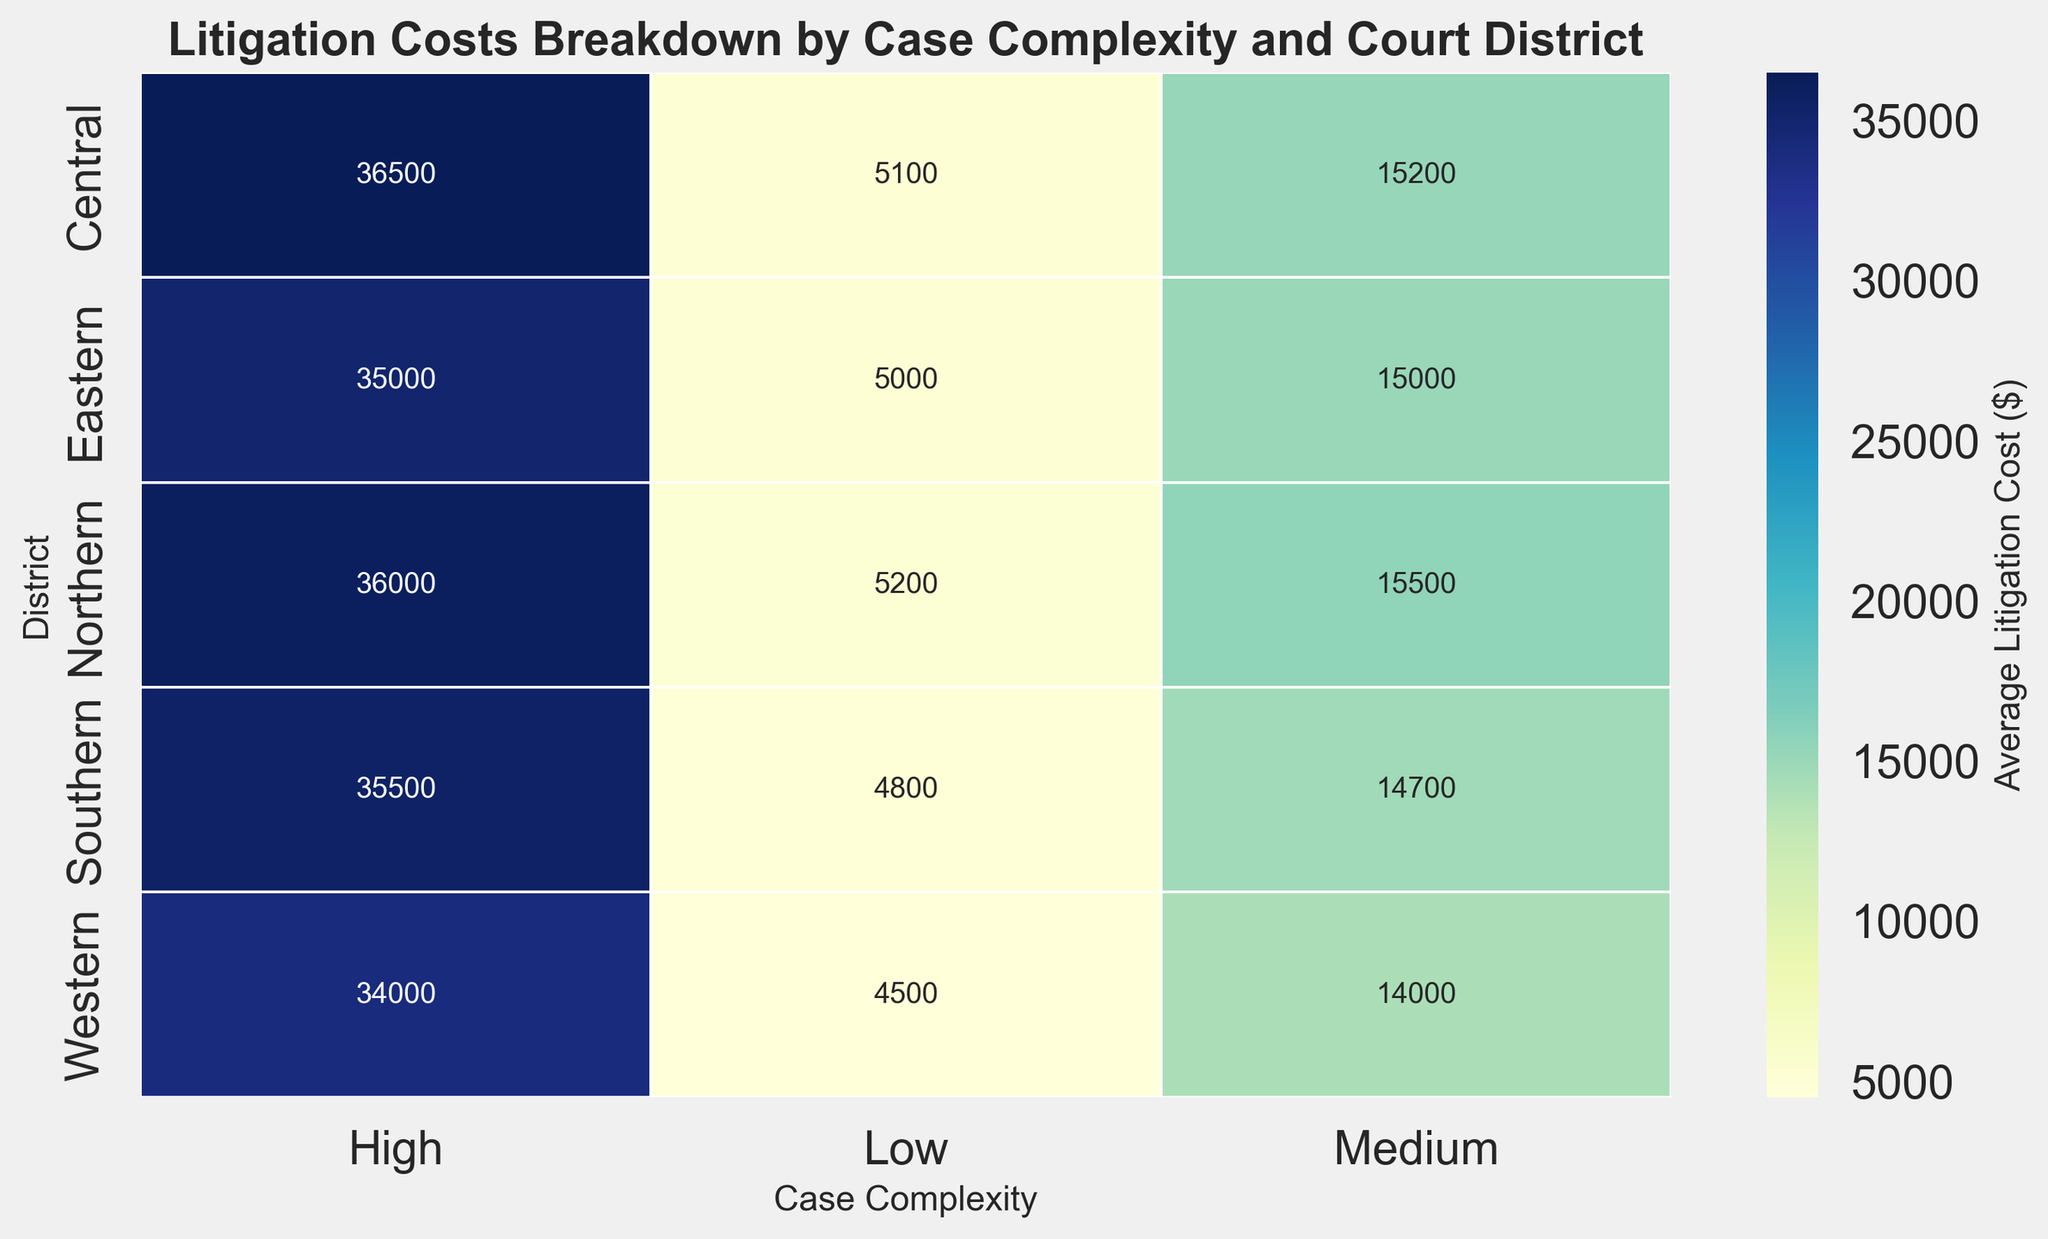What is the average litigation cost for medium complexity cases across all districts? To find the average litigation cost for medium complexity cases, sum the medium complexity values for all districts and then divide by the number of districts. The costs are 15000 (Eastern), 14000 (Western), 15500 (Northern), 14700 (Southern), and 15200 (Central). Sum these values: 15000 + 14000 + 15500 + 14700 + 15200 = 74400. Then divide by the number of districts (5): 74400 / 5 = 14880
Answer: 14880 Which district has the highest litigation cost for high complexity cases? Look at the high complexity case costs for each district: Eastern (35000), Western (34000), Northern (36000), Southern (35500), and Central (36500). The highest value is 36500 for Central district.
Answer: Central How does the average litigation cost for low complexity cases in the Eastern district compare to the Western district? The average litigation cost for low complexity cases in the Eastern district is 5000, while in the Western district, it is 4500. Compare these two values: 5000 is greater than 4500
Answer: Eastern (5000) is higher than Western (4500) Which case complexity level shows the most variation in litigation costs across different districts? To determine this, look at the range of costs for each complexity level. For low complexity: 5200 (max) - 4500 (min) = 700. For medium complexity: 15500 (max) - 14000 (min) = 1500. For high complexity: 36500 (max) - 34000 (min) = 2500. The high complexity level shows the most variation
Answer: High complexity What is the difference in average litigation costs for high complexity cases between Northern and Southern districts? The average litigation cost for high complexity cases in the Northern district is 36000 and in the Southern district is 35500. Subtract these values: 36000 - 35500 = 500
Answer: 500 Which district shows the least variation in litigation costs across all case complexities? Calculate the range of costs for each district. Eastern: 35000 - 5000 = 30000; Western: 34000 - 4500 = 29500; Northern: 36000 - 5200 = 30800; Southern: 35500 - 4800 = 30700; Central: 36500 - 5100 = 31400. The district with the smallest range is Western, with 29500
Answer: Western What is the combined litigation cost for low and medium complexity cases in the Central district? Add the litigation costs for low and medium complexity cases in the Central district: 5100 (low) + 15200 (medium) = 20300
Answer: 20300 What is the trend in litigation costs as case complexity increases in the Southern district? List the litigation costs in the Southern district by complexity: Low (4800), Medium (14700), High (35500). The costs increase as case complexity increases
Answer: Increasing Is the average litigation cost for high complexity cases greater in the Central district than the average for medium complexity cases across all districts? The litigation cost for high complexity cases in the Central district is 36500. For medium complexity cases across all districts, the costs are 15000 (Eastern), 14000 (Western), 15500 (Northern), 14700 (Southern), and 15200 (Central). The sum is 74400 and the average is 74400 / 5 = 14880. 36500 (Central high) is greater than 14880 (average medium)
Answer: Yes, it is greater 